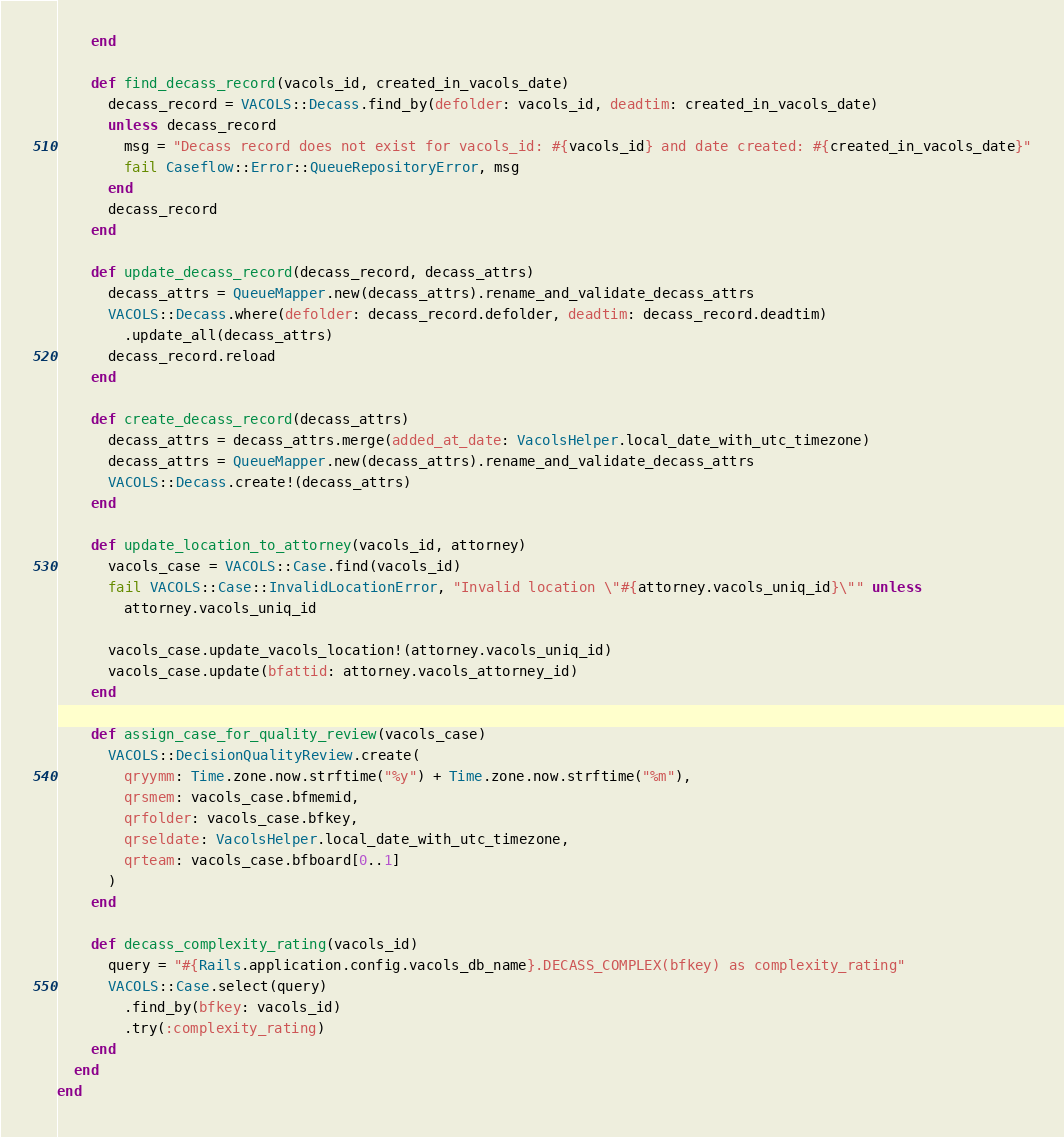<code> <loc_0><loc_0><loc_500><loc_500><_Ruby_>    end

    def find_decass_record(vacols_id, created_in_vacols_date)
      decass_record = VACOLS::Decass.find_by(defolder: vacols_id, deadtim: created_in_vacols_date)
      unless decass_record
        msg = "Decass record does not exist for vacols_id: #{vacols_id} and date created: #{created_in_vacols_date}"
        fail Caseflow::Error::QueueRepositoryError, msg
      end
      decass_record
    end

    def update_decass_record(decass_record, decass_attrs)
      decass_attrs = QueueMapper.new(decass_attrs).rename_and_validate_decass_attrs
      VACOLS::Decass.where(defolder: decass_record.defolder, deadtim: decass_record.deadtim)
        .update_all(decass_attrs)
      decass_record.reload
    end

    def create_decass_record(decass_attrs)
      decass_attrs = decass_attrs.merge(added_at_date: VacolsHelper.local_date_with_utc_timezone)
      decass_attrs = QueueMapper.new(decass_attrs).rename_and_validate_decass_attrs
      VACOLS::Decass.create!(decass_attrs)
    end

    def update_location_to_attorney(vacols_id, attorney)
      vacols_case = VACOLS::Case.find(vacols_id)
      fail VACOLS::Case::InvalidLocationError, "Invalid location \"#{attorney.vacols_uniq_id}\"" unless
        attorney.vacols_uniq_id

      vacols_case.update_vacols_location!(attorney.vacols_uniq_id)
      vacols_case.update(bfattid: attorney.vacols_attorney_id)
    end

    def assign_case_for_quality_review(vacols_case)
      VACOLS::DecisionQualityReview.create(
        qryymm: Time.zone.now.strftime("%y") + Time.zone.now.strftime("%m"),
        qrsmem: vacols_case.bfmemid,
        qrfolder: vacols_case.bfkey,
        qrseldate: VacolsHelper.local_date_with_utc_timezone,
        qrteam: vacols_case.bfboard[0..1]
      )
    end

    def decass_complexity_rating(vacols_id)
      query = "#{Rails.application.config.vacols_db_name}.DECASS_COMPLEX(bfkey) as complexity_rating"
      VACOLS::Case.select(query)
        .find_by(bfkey: vacols_id)
        .try(:complexity_rating)
    end
  end
end
</code> 